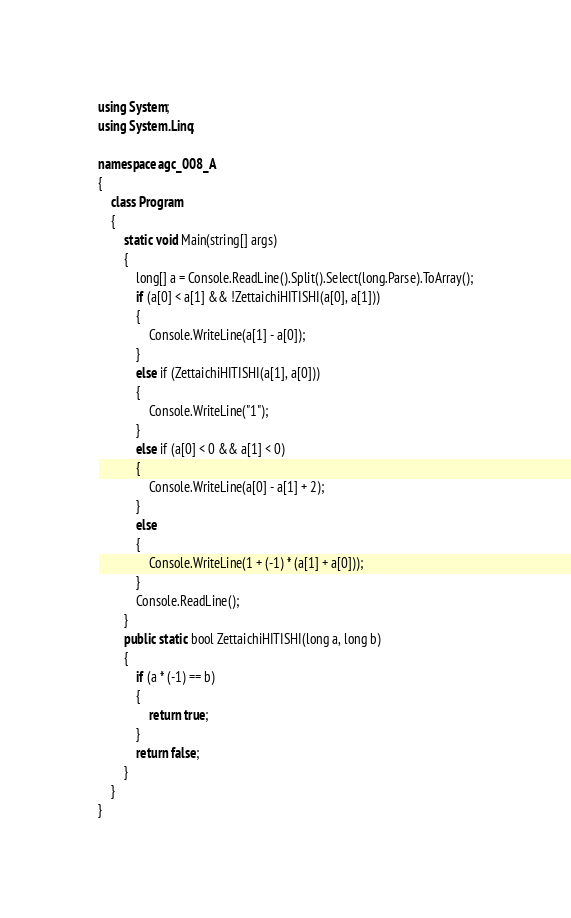<code> <loc_0><loc_0><loc_500><loc_500><_C#_>using System;
using System.Linq;

namespace agc_008_A
{
    class Program
    {
        static void Main(string[] args)
        {
            long[] a = Console.ReadLine().Split().Select(long.Parse).ToArray();
            if (a[0] < a[1] && !ZettaichiHITISHI(a[0], a[1]))
            {
                Console.WriteLine(a[1] - a[0]);
            }
            else if (ZettaichiHITISHI(a[1], a[0]))
            {
                Console.WriteLine("1");
            }
            else if (a[0] < 0 && a[1] < 0)
            {
                Console.WriteLine(a[0] - a[1] + 2);
            }
            else
            {
                Console.WriteLine(1 + (-1) * (a[1] + a[0]));
            }
            Console.ReadLine();
        }
        public static bool ZettaichiHITISHI(long a, long b)
        {
            if (a * (-1) == b)
            {
                return true;
            }
            return false;
        }
    }
}
</code> 